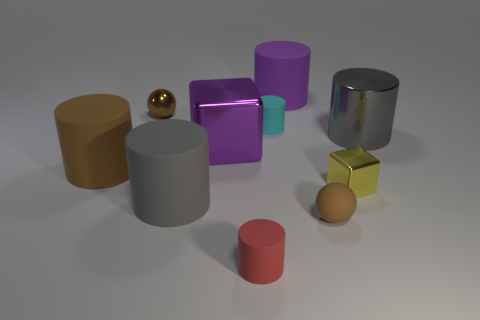Is the large cube made of the same material as the tiny yellow object?
Offer a terse response. Yes. How many other objects are the same color as the big metallic cylinder?
Give a very brief answer. 1. Are there more tiny red cubes than large things?
Provide a short and direct response. No. There is a brown metallic object; is it the same size as the sphere in front of the small cube?
Ensure brevity in your answer.  Yes. What is the color of the small cylinder that is behind the big purple shiny block?
Your response must be concise. Cyan. How many purple things are big cylinders or small spheres?
Provide a succinct answer. 1. What color is the tiny cube?
Your answer should be compact. Yellow. Is there anything else that has the same material as the tiny block?
Provide a succinct answer. Yes. Are there fewer large gray metal things that are on the left side of the small cyan cylinder than cubes in front of the gray metal object?
Offer a very short reply. Yes. What shape is the shiny thing that is left of the red matte object and on the right side of the metal ball?
Keep it short and to the point. Cube. 